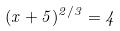<formula> <loc_0><loc_0><loc_500><loc_500>( x + 5 ) ^ { 2 / 3 } = 4</formula> 